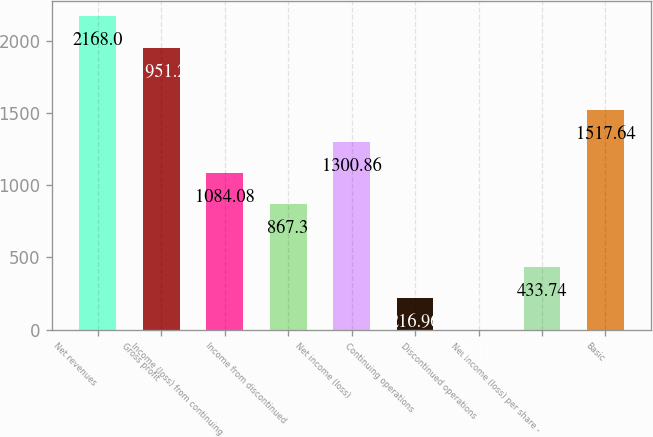Convert chart. <chart><loc_0><loc_0><loc_500><loc_500><bar_chart><fcel>Net revenues<fcel>Gross profit<fcel>Income (loss) from continuing<fcel>Income from discontinued<fcel>Net income (loss)<fcel>Continuing operations<fcel>Discontinued operations<fcel>Net income (loss) per share -<fcel>Basic<nl><fcel>2168<fcel>1951.2<fcel>1084.08<fcel>867.3<fcel>1300.86<fcel>216.96<fcel>0.18<fcel>433.74<fcel>1517.64<nl></chart> 